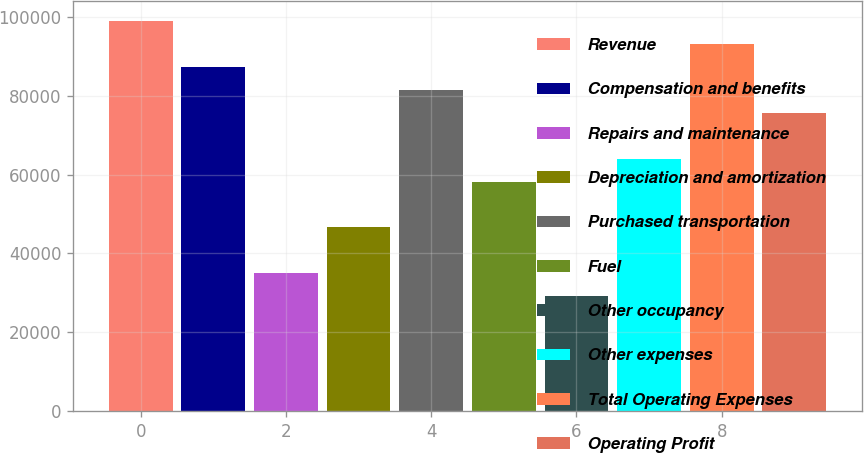<chart> <loc_0><loc_0><loc_500><loc_500><bar_chart><fcel>Revenue<fcel>Compensation and benefits<fcel>Repairs and maintenance<fcel>Depreciation and amortization<fcel>Purchased transportation<fcel>Fuel<fcel>Other occupancy<fcel>Other expenses<fcel>Total Operating Expenses<fcel>Operating Profit<nl><fcel>98992.1<fcel>87346.3<fcel>34940.5<fcel>46586.2<fcel>81523.5<fcel>58232<fcel>29117.6<fcel>64054.8<fcel>93169.2<fcel>75700.6<nl></chart> 